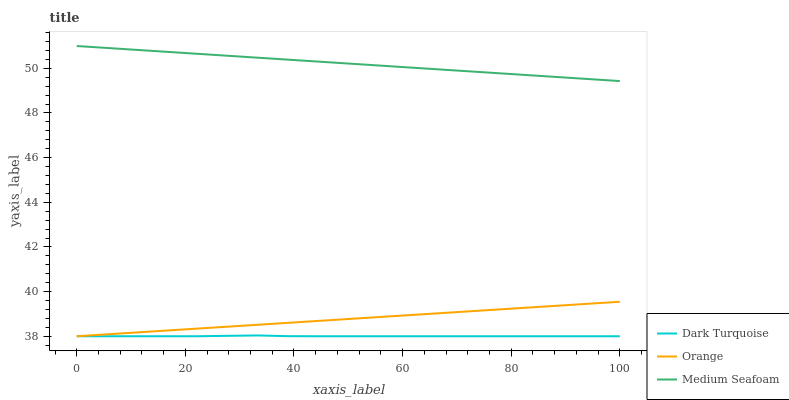Does Dark Turquoise have the minimum area under the curve?
Answer yes or no. Yes. Does Medium Seafoam have the maximum area under the curve?
Answer yes or no. Yes. Does Medium Seafoam have the minimum area under the curve?
Answer yes or no. No. Does Dark Turquoise have the maximum area under the curve?
Answer yes or no. No. Is Medium Seafoam the smoothest?
Answer yes or no. Yes. Is Dark Turquoise the roughest?
Answer yes or no. Yes. Is Dark Turquoise the smoothest?
Answer yes or no. No. Is Medium Seafoam the roughest?
Answer yes or no. No. Does Orange have the lowest value?
Answer yes or no. Yes. Does Medium Seafoam have the lowest value?
Answer yes or no. No. Does Medium Seafoam have the highest value?
Answer yes or no. Yes. Does Dark Turquoise have the highest value?
Answer yes or no. No. Is Orange less than Medium Seafoam?
Answer yes or no. Yes. Is Medium Seafoam greater than Dark Turquoise?
Answer yes or no. Yes. Does Dark Turquoise intersect Orange?
Answer yes or no. Yes. Is Dark Turquoise less than Orange?
Answer yes or no. No. Is Dark Turquoise greater than Orange?
Answer yes or no. No. Does Orange intersect Medium Seafoam?
Answer yes or no. No. 